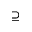Convert formula to latex. <formula><loc_0><loc_0><loc_500><loc_500>\supseteq</formula> 